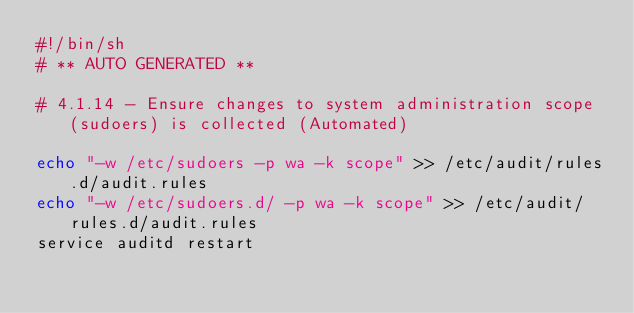<code> <loc_0><loc_0><loc_500><loc_500><_Bash_>#!/bin/sh
# ** AUTO GENERATED **

# 4.1.14 - Ensure changes to system administration scope (sudoers) is collected (Automated)

echo "-w /etc/sudoers -p wa -k scope" >> /etc/audit/rules.d/audit.rules
echo "-w /etc/sudoers.d/ -p wa -k scope" >> /etc/audit/rules.d/audit.rules
service auditd restart
</code> 